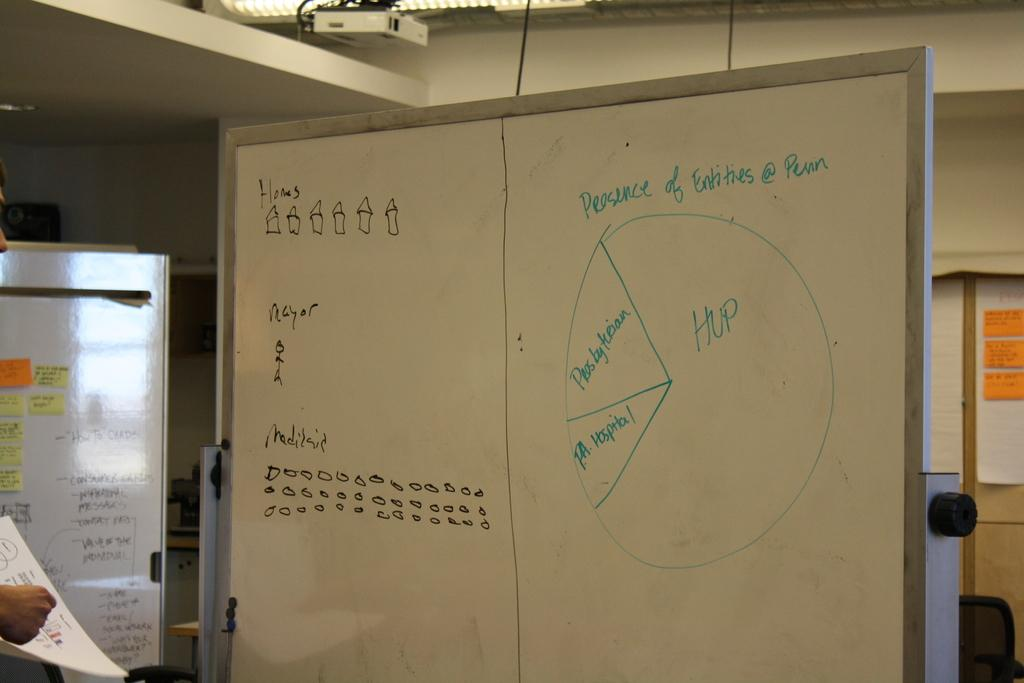<image>
Create a compact narrative representing the image presented. A pie chart drawn on a whiteboard shows the Presence of Entities. 